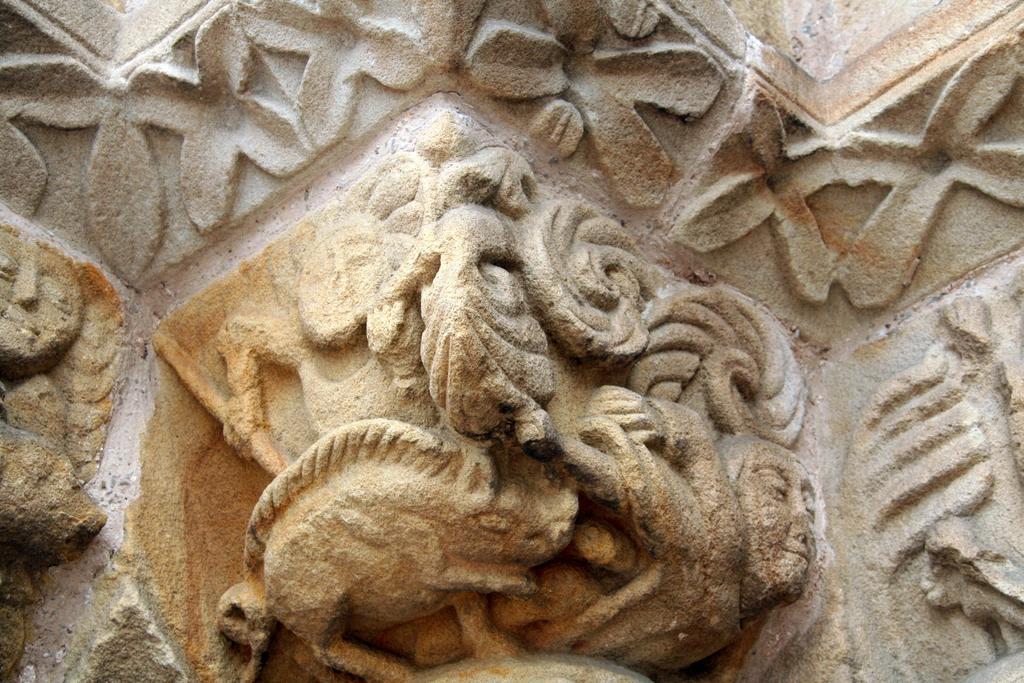Can you describe this image briefly? In this image we can see a wall with a design. 